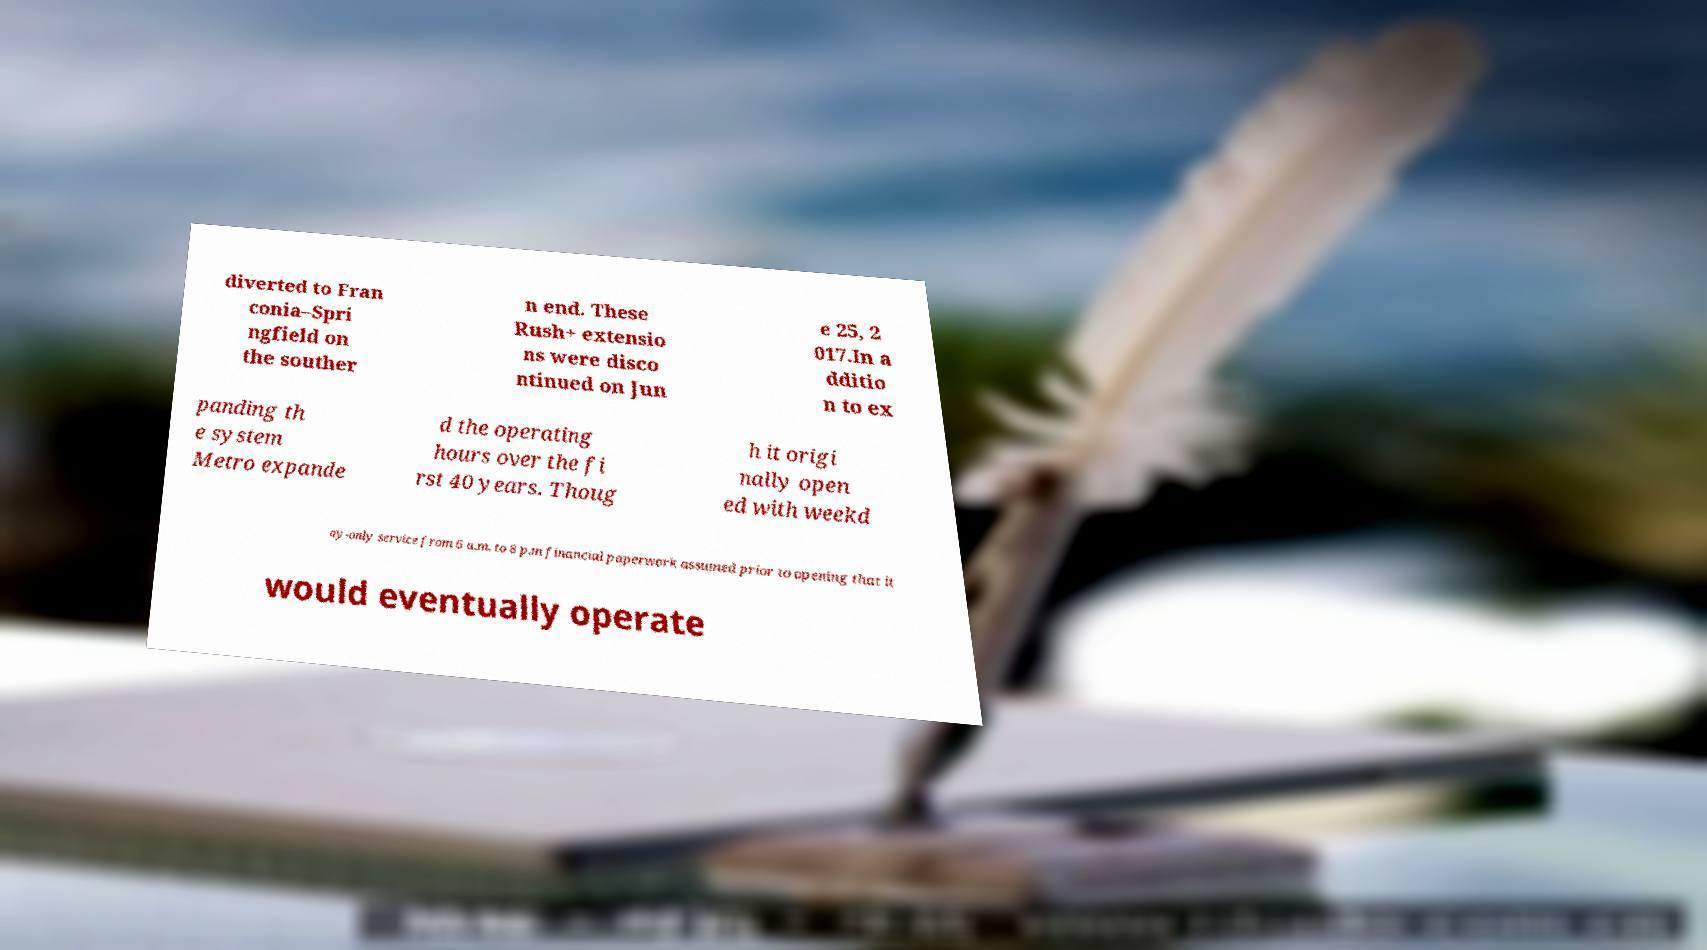Can you read and provide the text displayed in the image?This photo seems to have some interesting text. Can you extract and type it out for me? diverted to Fran conia–Spri ngfield on the souther n end. These Rush+ extensio ns were disco ntinued on Jun e 25, 2 017.In a dditio n to ex panding th e system Metro expande d the operating hours over the fi rst 40 years. Thoug h it origi nally open ed with weekd ay-only service from 6 a.m. to 8 p.m financial paperwork assumed prior to opening that it would eventually operate 